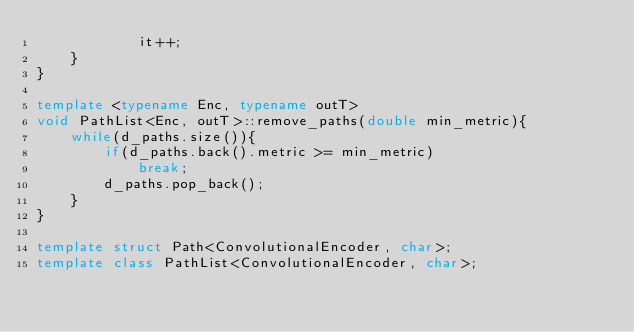Convert code to text. <code><loc_0><loc_0><loc_500><loc_500><_C++_>            it++;
    }
}

template <typename Enc, typename outT>
void PathList<Enc, outT>::remove_paths(double min_metric){
    while(d_paths.size()){
        if(d_paths.back().metric >= min_metric)
            break;
        d_paths.pop_back();
    }
}

template struct Path<ConvolutionalEncoder, char>;
template class PathList<ConvolutionalEncoder, char>;
</code> 